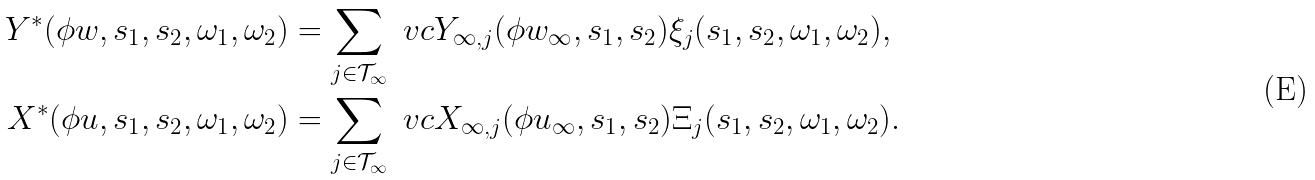Convert formula to latex. <formula><loc_0><loc_0><loc_500><loc_500>Y ^ { \ast } ( \phi w , s _ { 1 } , s _ { 2 } , \omega _ { 1 } , \omega _ { 2 } ) & = \sum _ { j \in \mathcal { T } _ { \infty } } \ v c Y _ { \infty , j } ( \phi w _ { \infty } , s _ { 1 } , s _ { 2 } ) \xi _ { j } ( s _ { 1 } , s _ { 2 } , \omega _ { 1 } , \omega _ { 2 } ) , \\ X ^ { \ast } ( \phi u , s _ { 1 } , s _ { 2 } , \omega _ { 1 } , \omega _ { 2 } ) & = \sum _ { j \in \mathcal { T } _ { \infty } } \ v c X _ { \infty , j } ( \phi u _ { \infty } , s _ { 1 } , s _ { 2 } ) \Xi _ { j } ( s _ { 1 } , s _ { 2 } , \omega _ { 1 } , \omega _ { 2 } ) .</formula> 